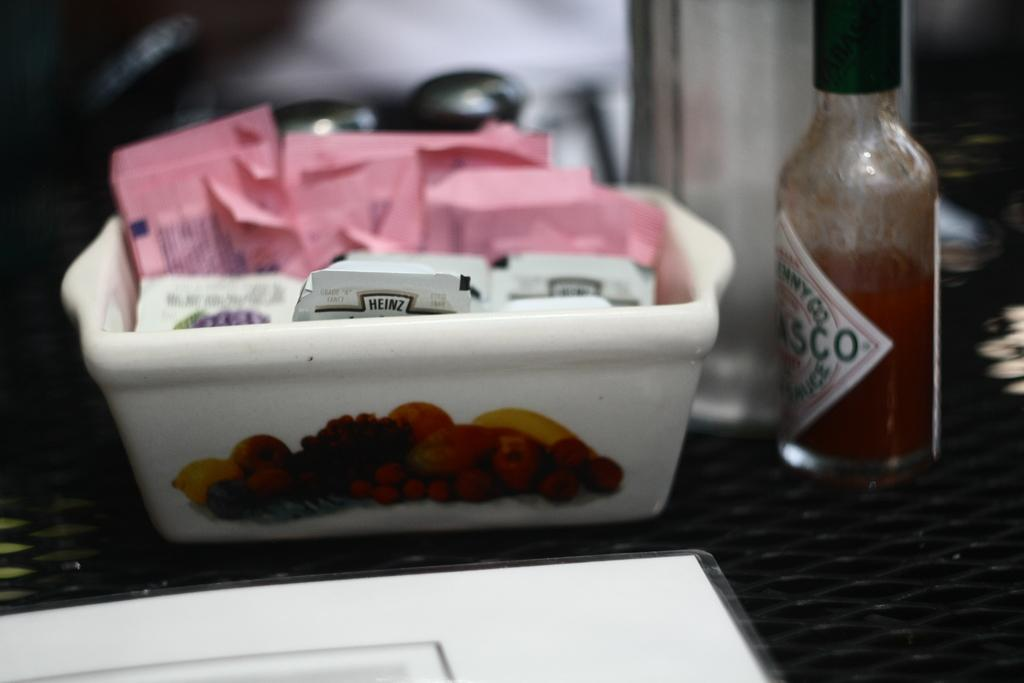<image>
Create a compact narrative representing the image presented. A white container with various heinz condiments in it. 